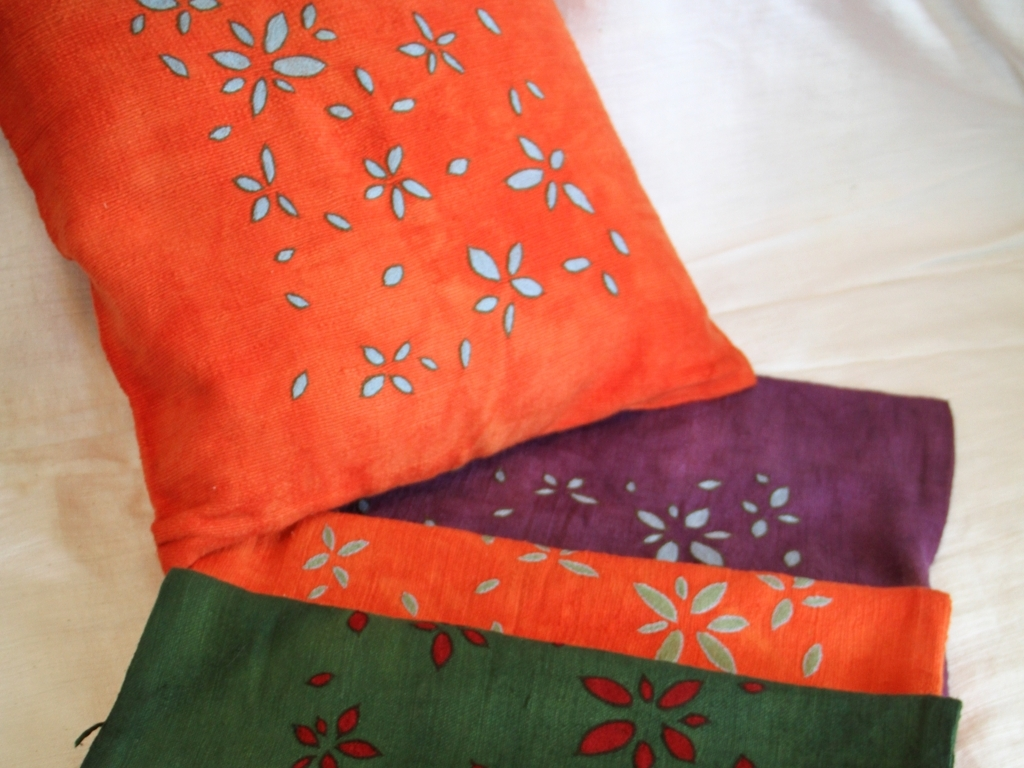What material do you think these fabrics are made of? While a tactile examination would be required for precision, the fabrics' appearance suggests they could be made of cotton or a cotton blend, given their texture and the way they drape. Such materials are popular for their breathability and versatility in crafting various textile items. 